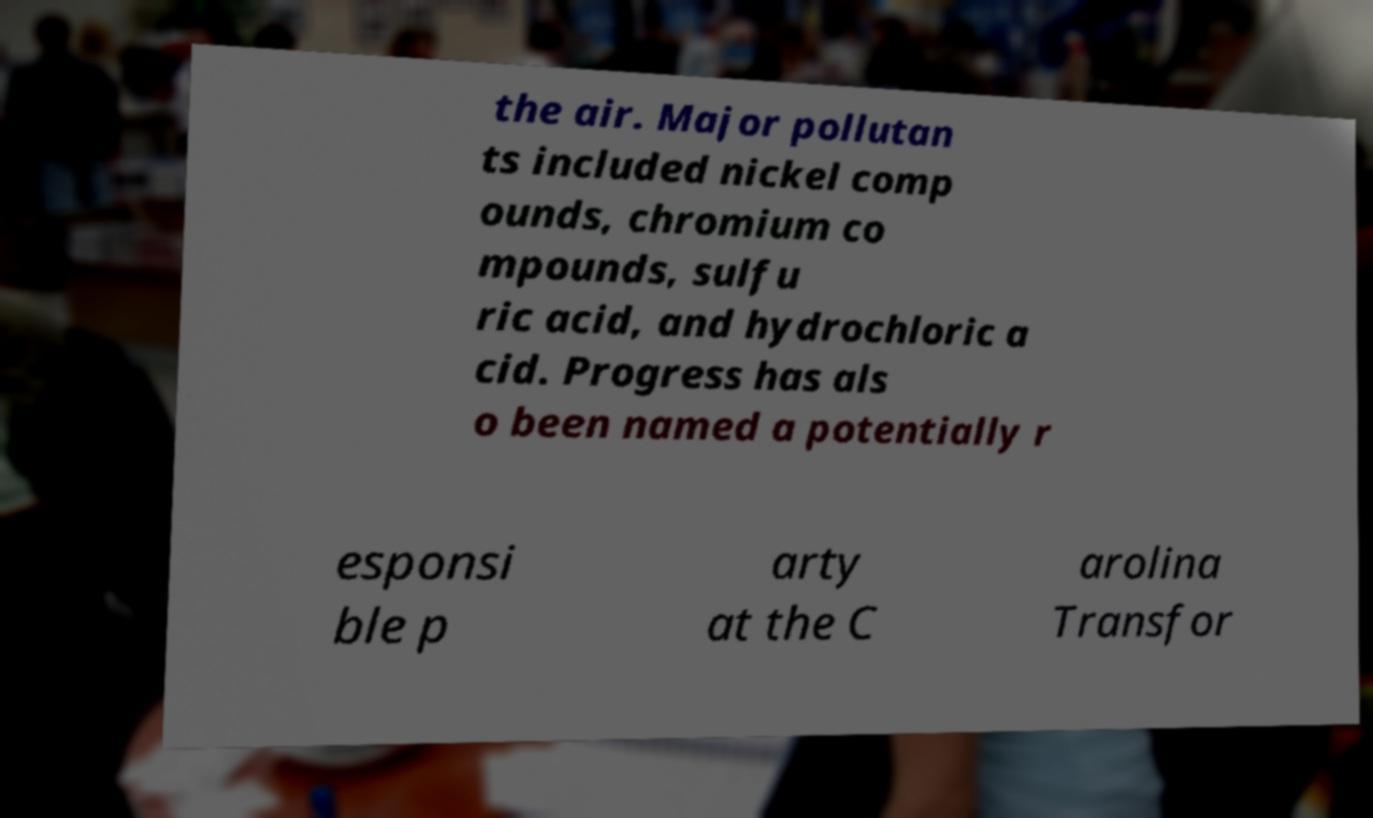Please identify and transcribe the text found in this image. the air. Major pollutan ts included nickel comp ounds, chromium co mpounds, sulfu ric acid, and hydrochloric a cid. Progress has als o been named a potentially r esponsi ble p arty at the C arolina Transfor 